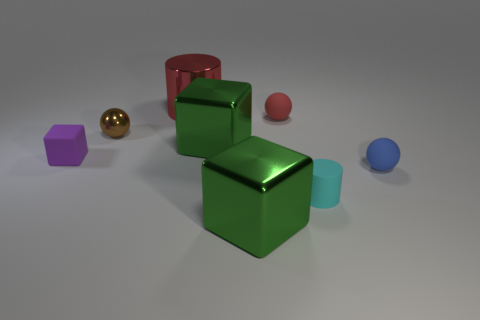Subtract all blue cylinders. Subtract all cyan cubes. How many cylinders are left? 2 Add 2 tiny spheres. How many objects exist? 10 Subtract all balls. How many objects are left? 5 Add 5 large green shiny cubes. How many large green shiny cubes exist? 7 Subtract 0 yellow cylinders. How many objects are left? 8 Subtract all rubber balls. Subtract all large green blocks. How many objects are left? 4 Add 2 balls. How many balls are left? 5 